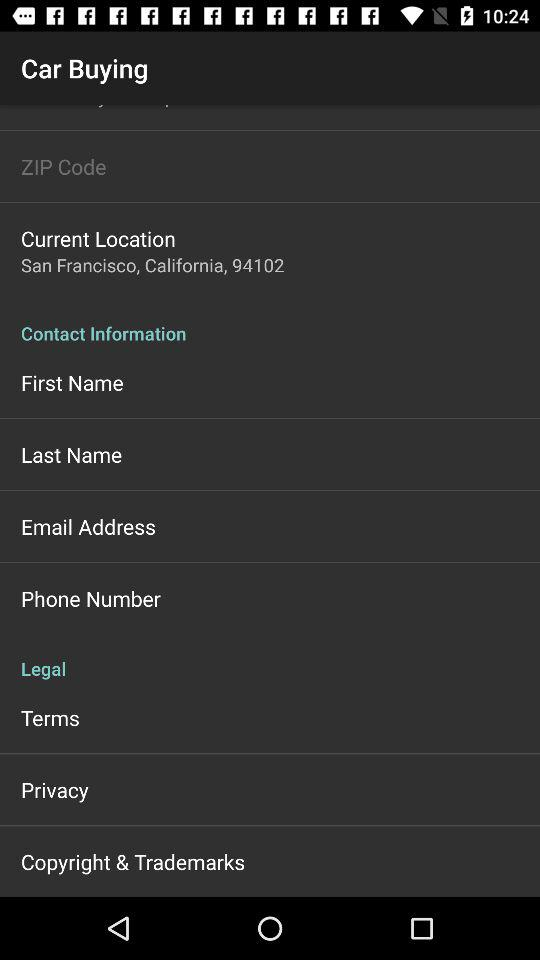What is the current location? The current location is San Francisco, California, 94102. 